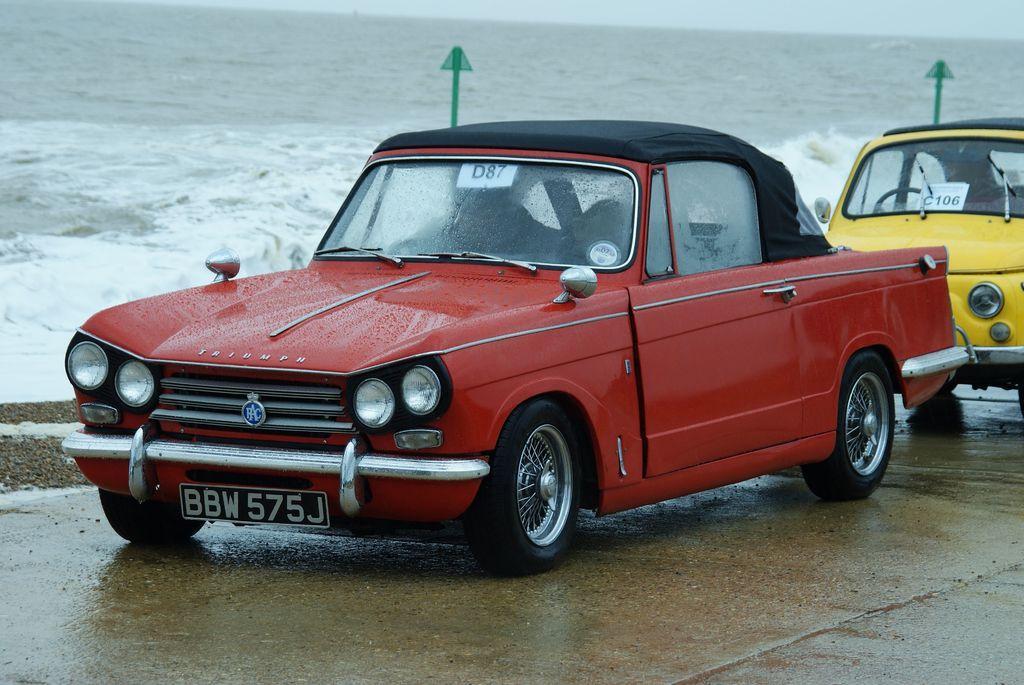In one or two sentences, can you explain what this image depicts? In this picture there is a red car on the road. Behind that I can see the yellow color van. Beside that I can see the sign boards. In the background I can see the ocean. At the top I can see the sky. 